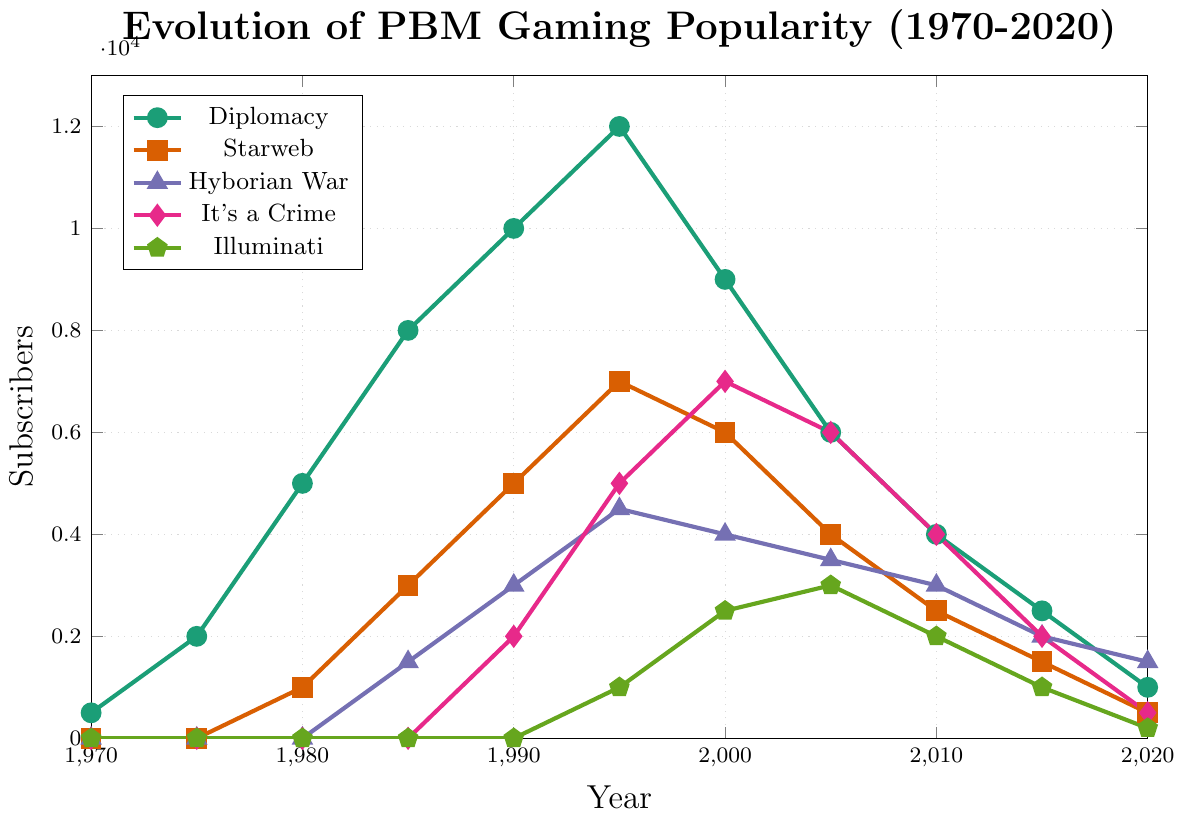What's the overall trend of Diplomacy subscriber numbers from 1970 to 2020? The Diplomacy subscriber numbers start from 500 in 1970, peak at 12000 in 1995, and then gradually decline to 1000 by 2020. The overall trend is an initial rise followed by a decline.
Answer: Rise, then decline Which game had the highest number of subscribers in 1995? To answer this, compare the subscriber numbers of all games in 1995: Diplomacy (12000), Starweb (7000), Hyborian War (4500), It's a Crime (5000), and Illuminati (1000). Diplomacy had the highest number of subscribers.
Answer: Diplomacy In which year did Illuminati reach its peak subscriber count? Evaluating the Illuminati subscriber numbers across the years: the numbers increase from 1995 onwards and peak at 3000 in 2005 before declining.
Answer: 2005 Which game saw a decline in subscribers every year from 2000 to 2020? Analyzing the subscriber numbers for each game from 2000 to 2020: Diplomacy shows a consistent decline from 2000 (9000) to 2020 (1000). Other games had fluctuations or increases in some years.
Answer: Diplomacy How did the subscriber numbers for Starweb change from 1980 to 1990? In 1980, Starweb had 1000 subscribers, which increased to 3000 in 1985 and then to 5000 in 1990. This shows a rising trend.
Answer: Increased What is the total number of subscribers for Hyborian War in the years 1985, 1995, and 2005? Add the subscriber numbers for Hyborian War in 1985 (1500), 1995 (4500), and 2005 (3500). The sum is 1500 + 4500 + 3500 = 9500.
Answer: 9500 Which game’s subscriber numbers remained at zero for the longest period of time? Comparing the periods during which each game had zero subscribers, Starweb, Hyborian War, It's a Crime, and Illuminati all have a period of zero subscribers, but Illuminati has the longest period starting from 1970 to 1990.
Answer: Illuminati If you sum the subscriber numbers of "It's a Crime" and "Illuminati" for the year 2000, what would the total be? Add the subscriber numbers for "It's a Crime" (7000) and "Illuminati" (2500) in the year 2000: 7000 + 2500 = 9500.
Answer: 9500 How does the popularity of Starweb change compared to Diplomacy from 1995 to 2020? From 1995 to 2020, Starweb subscribers decreased from 7000 to 500, and Diplomacy decreased from 12000 to 1000. In relative terms, both games saw a sharp decline, but Diplomacy always had higher numbers than Starweb in each year within this period.
Answer: Both declined, Diplomacy always higher Which game had the most significant growth spurt in subscribers between the years 1990 and 1995? Calculate the growth for each game between 1990 and 1995: Diplomacy (2000), Starweb (2000), Hyborian War (1500), It's a Crime (3000), and Illuminati (1000). It's a Crime had the most significant growth in this period.
Answer: It's a Crime 